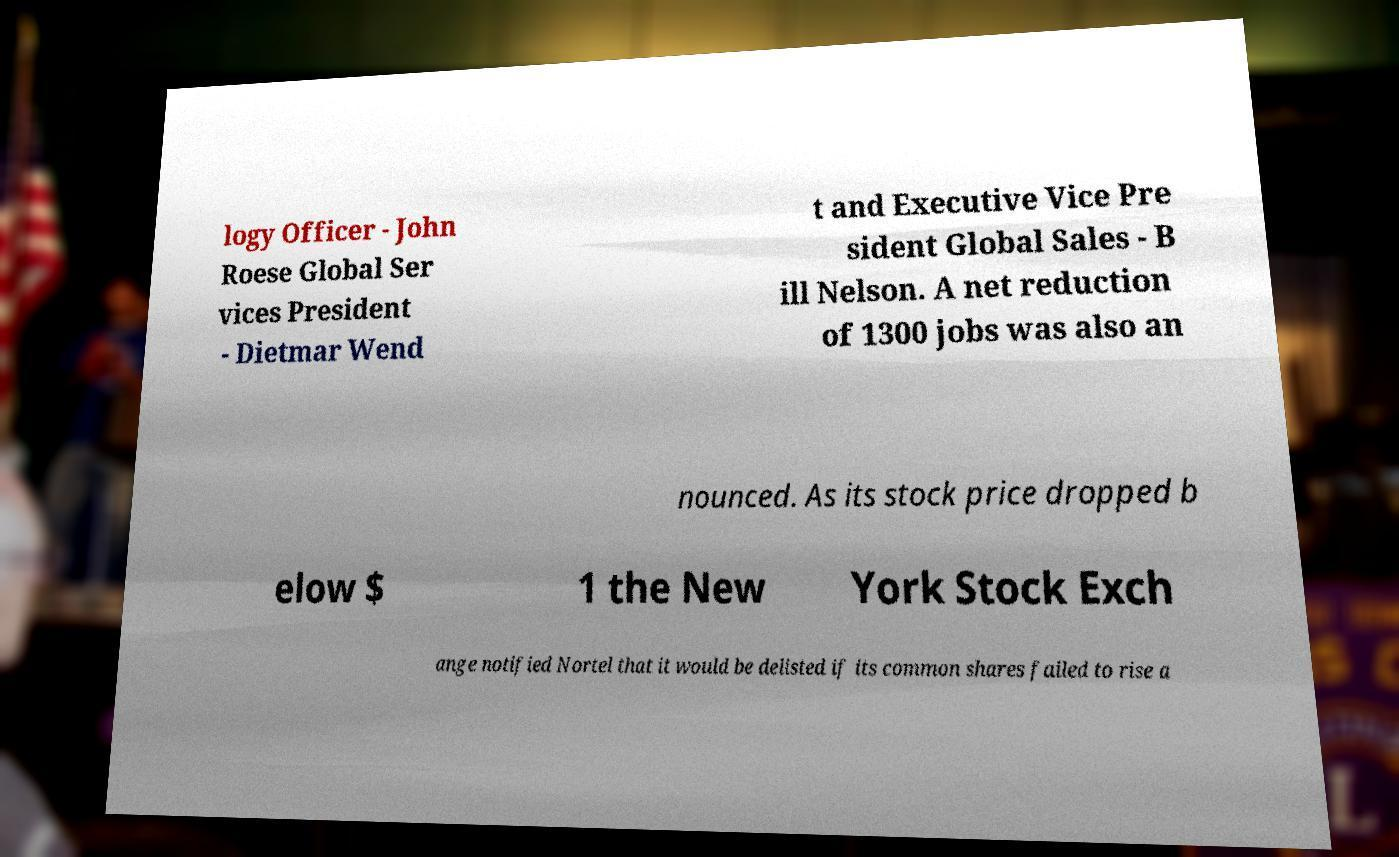I need the written content from this picture converted into text. Can you do that? logy Officer - John Roese Global Ser vices President - Dietmar Wend t and Executive Vice Pre sident Global Sales - B ill Nelson. A net reduction of 1300 jobs was also an nounced. As its stock price dropped b elow $ 1 the New York Stock Exch ange notified Nortel that it would be delisted if its common shares failed to rise a 